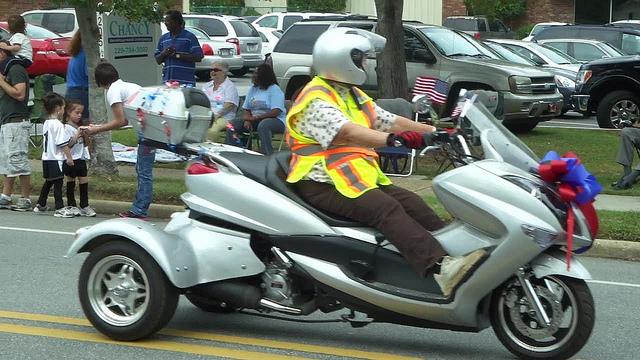What is the person riding?
Write a very short answer. Motorcycle. What vehicle is this?
Write a very short answer. Motorcycle. Is there a small cute dog on the scooter?
Write a very short answer. No. Is the man is wearing any helmet?
Answer briefly. Yes. What is on the front of the bike?
Answer briefly. Bow. 